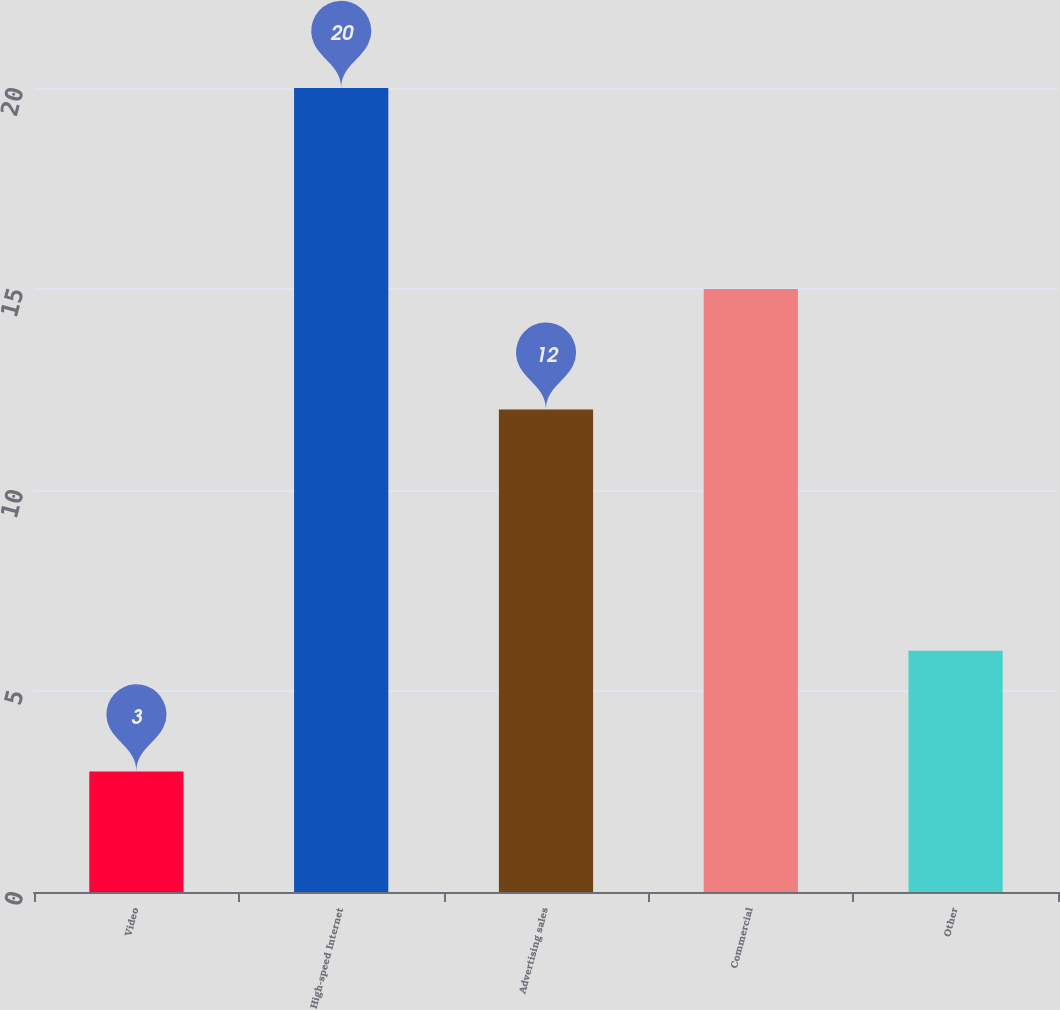Convert chart to OTSL. <chart><loc_0><loc_0><loc_500><loc_500><bar_chart><fcel>Video<fcel>High-speed Internet<fcel>Advertising sales<fcel>Commercial<fcel>Other<nl><fcel>3<fcel>20<fcel>12<fcel>15<fcel>6<nl></chart> 